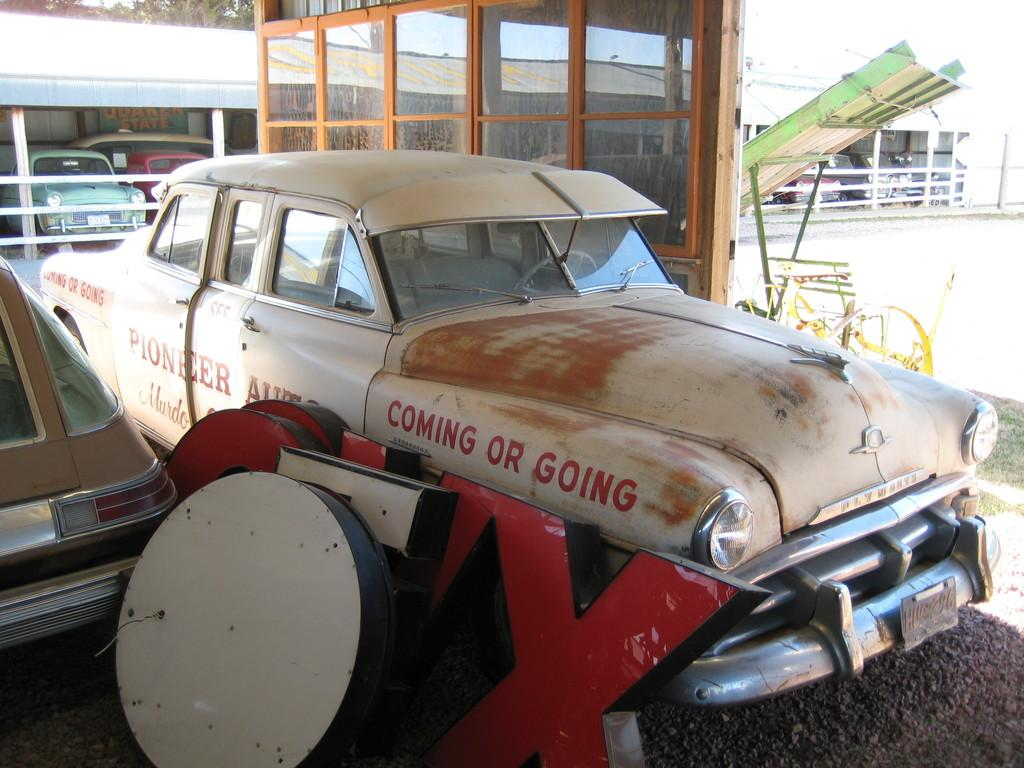Provide a one-sentence caption for the provided image. An old white car in a lot with the words "coming or going" on its side. 